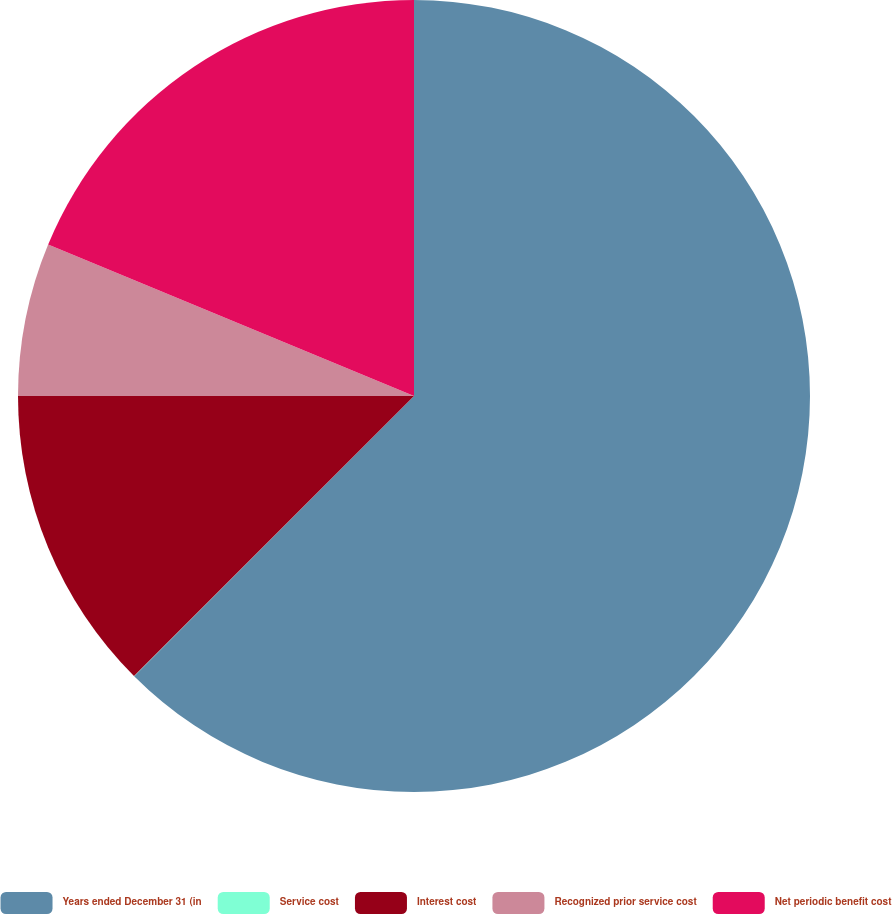Convert chart to OTSL. <chart><loc_0><loc_0><loc_500><loc_500><pie_chart><fcel>Years ended December 31 (in<fcel>Service cost<fcel>Interest cost<fcel>Recognized prior service cost<fcel>Net periodic benefit cost<nl><fcel>62.49%<fcel>0.01%<fcel>12.5%<fcel>6.25%<fcel>18.75%<nl></chart> 